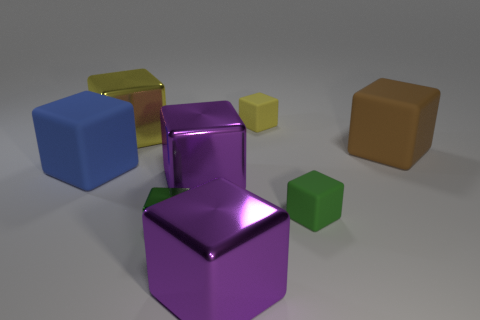Subtract all large brown blocks. How many blocks are left? 7 Subtract all yellow blocks. How many blocks are left? 6 Subtract 1 cubes. How many cubes are left? 7 Subtract all gray blocks. Subtract all green balls. How many blocks are left? 8 Add 2 yellow blocks. How many objects exist? 10 Add 3 yellow metal objects. How many yellow metal objects exist? 4 Subtract 0 yellow balls. How many objects are left? 8 Subtract all tiny yellow rubber blocks. Subtract all brown metallic cylinders. How many objects are left? 7 Add 2 small things. How many small things are left? 5 